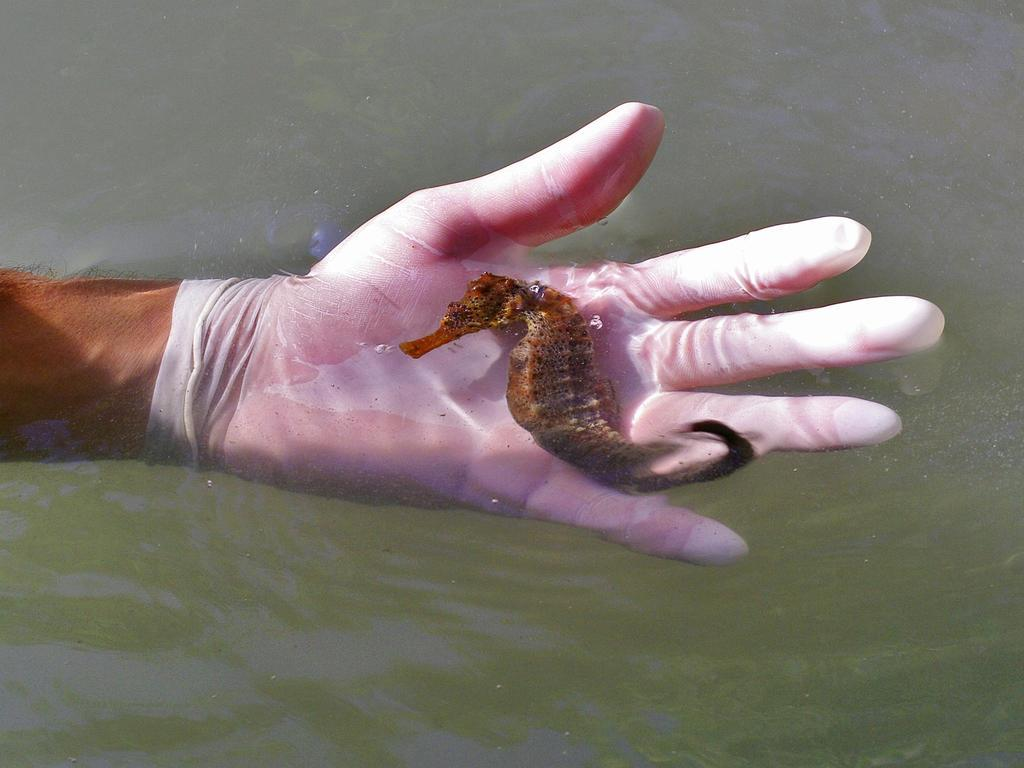What is the main subject of the image? The main subject of the image is a person's hand. Can you describe the hand in the image? The hand is wearing a glove. What is the hand holding? The hand is holding a seahorse. What can be seen in the background of the image? There is a water body visible in the background of the image. What type of committee is meeting near the water body in the image? There is no committee present in the image, and the image does not depict a meeting. 